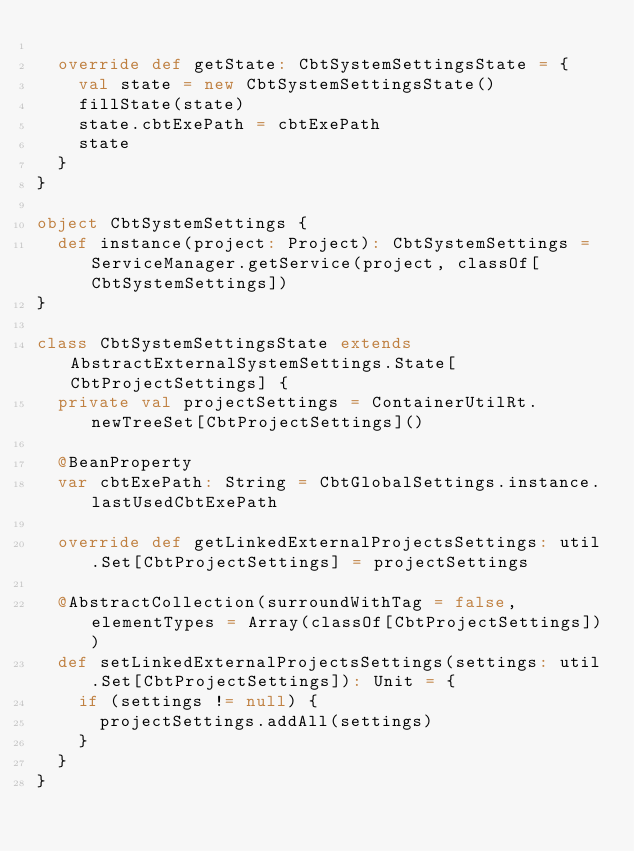Convert code to text. <code><loc_0><loc_0><loc_500><loc_500><_Scala_>
  override def getState: CbtSystemSettingsState = {
    val state = new CbtSystemSettingsState()
    fillState(state)
    state.cbtExePath = cbtExePath
    state
  }
}

object CbtSystemSettings {
  def instance(project: Project): CbtSystemSettings = ServiceManager.getService(project, classOf[CbtSystemSettings])
}

class CbtSystemSettingsState extends AbstractExternalSystemSettings.State[CbtProjectSettings] {
  private val projectSettings = ContainerUtilRt.newTreeSet[CbtProjectSettings]()

  @BeanProperty
  var cbtExePath: String = CbtGlobalSettings.instance.lastUsedCbtExePath

  override def getLinkedExternalProjectsSettings: util.Set[CbtProjectSettings] = projectSettings

  @AbstractCollection(surroundWithTag = false, elementTypes = Array(classOf[CbtProjectSettings]))
  def setLinkedExternalProjectsSettings(settings: util.Set[CbtProjectSettings]): Unit = {
    if (settings != null) {
      projectSettings.addAll(settings)
    }
  }
}</code> 